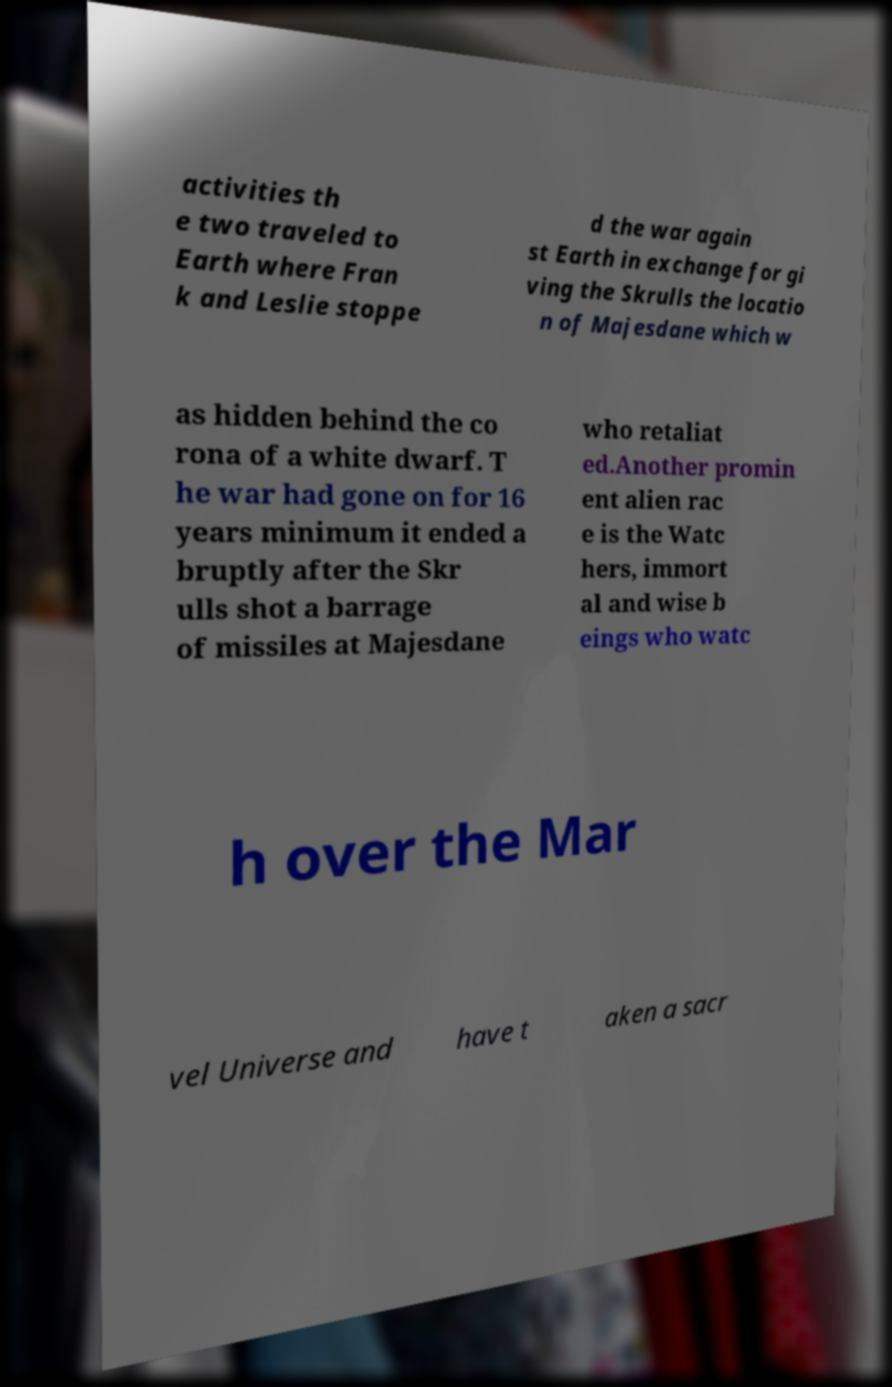Can you accurately transcribe the text from the provided image for me? activities th e two traveled to Earth where Fran k and Leslie stoppe d the war again st Earth in exchange for gi ving the Skrulls the locatio n of Majesdane which w as hidden behind the co rona of a white dwarf. T he war had gone on for 16 years minimum it ended a bruptly after the Skr ulls shot a barrage of missiles at Majesdane who retaliat ed.Another promin ent alien rac e is the Watc hers, immort al and wise b eings who watc h over the Mar vel Universe and have t aken a sacr 